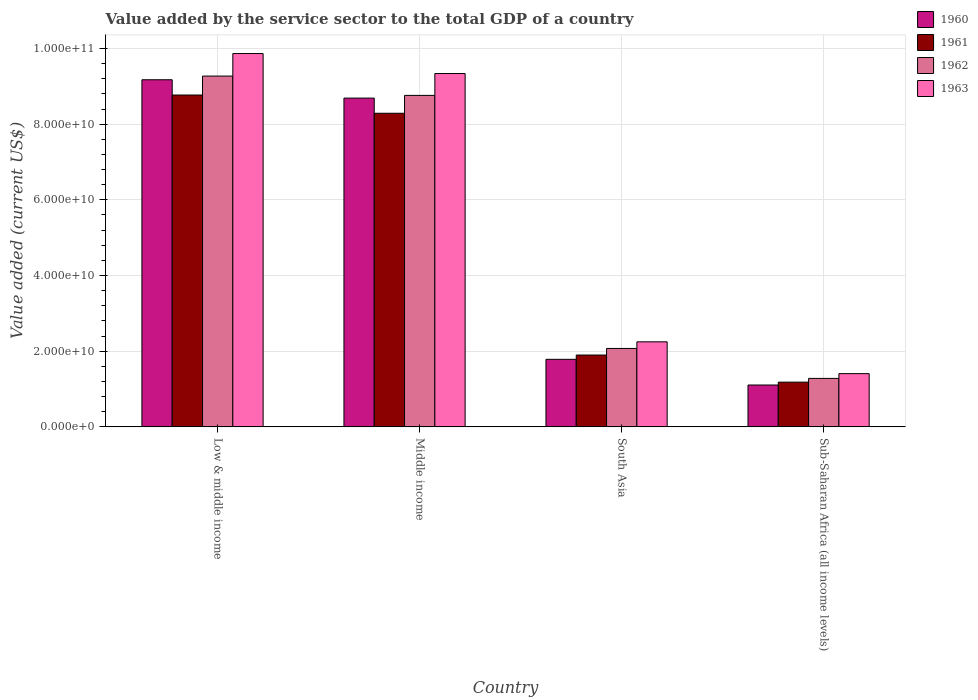How many groups of bars are there?
Offer a very short reply. 4. Are the number of bars per tick equal to the number of legend labels?
Give a very brief answer. Yes. How many bars are there on the 2nd tick from the left?
Your answer should be very brief. 4. What is the value added by the service sector to the total GDP in 1961 in Low & middle income?
Your answer should be compact. 8.77e+1. Across all countries, what is the maximum value added by the service sector to the total GDP in 1962?
Your answer should be very brief. 9.27e+1. Across all countries, what is the minimum value added by the service sector to the total GDP in 1960?
Your response must be concise. 1.11e+1. In which country was the value added by the service sector to the total GDP in 1962 minimum?
Provide a succinct answer. Sub-Saharan Africa (all income levels). What is the total value added by the service sector to the total GDP in 1963 in the graph?
Provide a short and direct response. 2.29e+11. What is the difference between the value added by the service sector to the total GDP in 1963 in Low & middle income and that in South Asia?
Give a very brief answer. 7.62e+1. What is the difference between the value added by the service sector to the total GDP in 1962 in Sub-Saharan Africa (all income levels) and the value added by the service sector to the total GDP in 1963 in Low & middle income?
Make the answer very short. -8.58e+1. What is the average value added by the service sector to the total GDP in 1960 per country?
Your response must be concise. 5.19e+1. What is the difference between the value added by the service sector to the total GDP of/in 1961 and value added by the service sector to the total GDP of/in 1963 in Middle income?
Your response must be concise. -1.05e+1. What is the ratio of the value added by the service sector to the total GDP in 1962 in South Asia to that in Sub-Saharan Africa (all income levels)?
Your response must be concise. 1.62. What is the difference between the highest and the second highest value added by the service sector to the total GDP in 1963?
Your response must be concise. -5.28e+09. What is the difference between the highest and the lowest value added by the service sector to the total GDP in 1960?
Provide a short and direct response. 8.07e+1. What does the 3rd bar from the left in South Asia represents?
Provide a succinct answer. 1962. How many countries are there in the graph?
Give a very brief answer. 4. What is the difference between two consecutive major ticks on the Y-axis?
Provide a succinct answer. 2.00e+1. Does the graph contain grids?
Offer a terse response. Yes. How are the legend labels stacked?
Keep it short and to the point. Vertical. What is the title of the graph?
Offer a terse response. Value added by the service sector to the total GDP of a country. Does "1974" appear as one of the legend labels in the graph?
Your response must be concise. No. What is the label or title of the Y-axis?
Provide a succinct answer. Value added (current US$). What is the Value added (current US$) in 1960 in Low & middle income?
Your answer should be compact. 9.17e+1. What is the Value added (current US$) in 1961 in Low & middle income?
Offer a very short reply. 8.77e+1. What is the Value added (current US$) in 1962 in Low & middle income?
Ensure brevity in your answer.  9.27e+1. What is the Value added (current US$) of 1963 in Low & middle income?
Keep it short and to the point. 9.87e+1. What is the Value added (current US$) of 1960 in Middle income?
Offer a very short reply. 8.69e+1. What is the Value added (current US$) of 1961 in Middle income?
Your response must be concise. 8.29e+1. What is the Value added (current US$) of 1962 in Middle income?
Provide a short and direct response. 8.76e+1. What is the Value added (current US$) of 1963 in Middle income?
Your response must be concise. 9.34e+1. What is the Value added (current US$) of 1960 in South Asia?
Offer a terse response. 1.79e+1. What is the Value added (current US$) of 1961 in South Asia?
Ensure brevity in your answer.  1.90e+1. What is the Value added (current US$) in 1962 in South Asia?
Your response must be concise. 2.07e+1. What is the Value added (current US$) of 1963 in South Asia?
Your answer should be very brief. 2.25e+1. What is the Value added (current US$) of 1960 in Sub-Saharan Africa (all income levels)?
Your response must be concise. 1.11e+1. What is the Value added (current US$) in 1961 in Sub-Saharan Africa (all income levels)?
Offer a terse response. 1.18e+1. What is the Value added (current US$) of 1962 in Sub-Saharan Africa (all income levels)?
Your answer should be very brief. 1.28e+1. What is the Value added (current US$) in 1963 in Sub-Saharan Africa (all income levels)?
Make the answer very short. 1.41e+1. Across all countries, what is the maximum Value added (current US$) of 1960?
Make the answer very short. 9.17e+1. Across all countries, what is the maximum Value added (current US$) in 1961?
Keep it short and to the point. 8.77e+1. Across all countries, what is the maximum Value added (current US$) in 1962?
Offer a terse response. 9.27e+1. Across all countries, what is the maximum Value added (current US$) in 1963?
Provide a succinct answer. 9.87e+1. Across all countries, what is the minimum Value added (current US$) of 1960?
Provide a succinct answer. 1.11e+1. Across all countries, what is the minimum Value added (current US$) of 1961?
Your answer should be very brief. 1.18e+1. Across all countries, what is the minimum Value added (current US$) of 1962?
Your answer should be very brief. 1.28e+1. Across all countries, what is the minimum Value added (current US$) of 1963?
Your response must be concise. 1.41e+1. What is the total Value added (current US$) in 1960 in the graph?
Make the answer very short. 2.08e+11. What is the total Value added (current US$) in 1961 in the graph?
Your answer should be compact. 2.01e+11. What is the total Value added (current US$) of 1962 in the graph?
Keep it short and to the point. 2.14e+11. What is the total Value added (current US$) of 1963 in the graph?
Your response must be concise. 2.29e+11. What is the difference between the Value added (current US$) of 1960 in Low & middle income and that in Middle income?
Provide a succinct answer. 4.84e+09. What is the difference between the Value added (current US$) in 1961 in Low & middle income and that in Middle income?
Offer a terse response. 4.82e+09. What is the difference between the Value added (current US$) of 1962 in Low & middle income and that in Middle income?
Make the answer very short. 5.11e+09. What is the difference between the Value added (current US$) of 1963 in Low & middle income and that in Middle income?
Provide a short and direct response. 5.28e+09. What is the difference between the Value added (current US$) of 1960 in Low & middle income and that in South Asia?
Provide a succinct answer. 7.39e+1. What is the difference between the Value added (current US$) of 1961 in Low & middle income and that in South Asia?
Provide a short and direct response. 6.87e+1. What is the difference between the Value added (current US$) of 1962 in Low & middle income and that in South Asia?
Keep it short and to the point. 7.20e+1. What is the difference between the Value added (current US$) in 1963 in Low & middle income and that in South Asia?
Offer a terse response. 7.62e+1. What is the difference between the Value added (current US$) in 1960 in Low & middle income and that in Sub-Saharan Africa (all income levels)?
Ensure brevity in your answer.  8.07e+1. What is the difference between the Value added (current US$) of 1961 in Low & middle income and that in Sub-Saharan Africa (all income levels)?
Give a very brief answer. 7.59e+1. What is the difference between the Value added (current US$) of 1962 in Low & middle income and that in Sub-Saharan Africa (all income levels)?
Offer a very short reply. 7.99e+1. What is the difference between the Value added (current US$) of 1963 in Low & middle income and that in Sub-Saharan Africa (all income levels)?
Your response must be concise. 8.46e+1. What is the difference between the Value added (current US$) in 1960 in Middle income and that in South Asia?
Offer a very short reply. 6.90e+1. What is the difference between the Value added (current US$) of 1961 in Middle income and that in South Asia?
Keep it short and to the point. 6.39e+1. What is the difference between the Value added (current US$) of 1962 in Middle income and that in South Asia?
Ensure brevity in your answer.  6.69e+1. What is the difference between the Value added (current US$) of 1963 in Middle income and that in South Asia?
Offer a terse response. 7.09e+1. What is the difference between the Value added (current US$) of 1960 in Middle income and that in Sub-Saharan Africa (all income levels)?
Offer a terse response. 7.58e+1. What is the difference between the Value added (current US$) of 1961 in Middle income and that in Sub-Saharan Africa (all income levels)?
Provide a short and direct response. 7.11e+1. What is the difference between the Value added (current US$) in 1962 in Middle income and that in Sub-Saharan Africa (all income levels)?
Offer a very short reply. 7.48e+1. What is the difference between the Value added (current US$) in 1963 in Middle income and that in Sub-Saharan Africa (all income levels)?
Offer a very short reply. 7.93e+1. What is the difference between the Value added (current US$) of 1960 in South Asia and that in Sub-Saharan Africa (all income levels)?
Make the answer very short. 6.79e+09. What is the difference between the Value added (current US$) in 1961 in South Asia and that in Sub-Saharan Africa (all income levels)?
Give a very brief answer. 7.17e+09. What is the difference between the Value added (current US$) of 1962 in South Asia and that in Sub-Saharan Africa (all income levels)?
Your response must be concise. 7.91e+09. What is the difference between the Value added (current US$) in 1963 in South Asia and that in Sub-Saharan Africa (all income levels)?
Provide a short and direct response. 8.41e+09. What is the difference between the Value added (current US$) in 1960 in Low & middle income and the Value added (current US$) in 1961 in Middle income?
Your answer should be compact. 8.85e+09. What is the difference between the Value added (current US$) in 1960 in Low & middle income and the Value added (current US$) in 1962 in Middle income?
Your response must be concise. 4.13e+09. What is the difference between the Value added (current US$) in 1960 in Low & middle income and the Value added (current US$) in 1963 in Middle income?
Provide a succinct answer. -1.65e+09. What is the difference between the Value added (current US$) of 1961 in Low & middle income and the Value added (current US$) of 1962 in Middle income?
Offer a very short reply. 9.90e+07. What is the difference between the Value added (current US$) in 1961 in Low & middle income and the Value added (current US$) in 1963 in Middle income?
Give a very brief answer. -5.68e+09. What is the difference between the Value added (current US$) of 1962 in Low & middle income and the Value added (current US$) of 1963 in Middle income?
Your answer should be compact. -6.73e+08. What is the difference between the Value added (current US$) of 1960 in Low & middle income and the Value added (current US$) of 1961 in South Asia?
Provide a short and direct response. 7.27e+1. What is the difference between the Value added (current US$) of 1960 in Low & middle income and the Value added (current US$) of 1962 in South Asia?
Your answer should be very brief. 7.10e+1. What is the difference between the Value added (current US$) of 1960 in Low & middle income and the Value added (current US$) of 1963 in South Asia?
Keep it short and to the point. 6.93e+1. What is the difference between the Value added (current US$) in 1961 in Low & middle income and the Value added (current US$) in 1962 in South Asia?
Your answer should be very brief. 6.70e+1. What is the difference between the Value added (current US$) in 1961 in Low & middle income and the Value added (current US$) in 1963 in South Asia?
Your response must be concise. 6.52e+1. What is the difference between the Value added (current US$) of 1962 in Low & middle income and the Value added (current US$) of 1963 in South Asia?
Make the answer very short. 7.02e+1. What is the difference between the Value added (current US$) in 1960 in Low & middle income and the Value added (current US$) in 1961 in Sub-Saharan Africa (all income levels)?
Provide a succinct answer. 7.99e+1. What is the difference between the Value added (current US$) in 1960 in Low & middle income and the Value added (current US$) in 1962 in Sub-Saharan Africa (all income levels)?
Provide a succinct answer. 7.89e+1. What is the difference between the Value added (current US$) of 1960 in Low & middle income and the Value added (current US$) of 1963 in Sub-Saharan Africa (all income levels)?
Give a very brief answer. 7.77e+1. What is the difference between the Value added (current US$) in 1961 in Low & middle income and the Value added (current US$) in 1962 in Sub-Saharan Africa (all income levels)?
Provide a short and direct response. 7.49e+1. What is the difference between the Value added (current US$) of 1961 in Low & middle income and the Value added (current US$) of 1963 in Sub-Saharan Africa (all income levels)?
Offer a terse response. 7.36e+1. What is the difference between the Value added (current US$) of 1962 in Low & middle income and the Value added (current US$) of 1963 in Sub-Saharan Africa (all income levels)?
Provide a succinct answer. 7.86e+1. What is the difference between the Value added (current US$) of 1960 in Middle income and the Value added (current US$) of 1961 in South Asia?
Keep it short and to the point. 6.79e+1. What is the difference between the Value added (current US$) in 1960 in Middle income and the Value added (current US$) in 1962 in South Asia?
Keep it short and to the point. 6.62e+1. What is the difference between the Value added (current US$) of 1960 in Middle income and the Value added (current US$) of 1963 in South Asia?
Offer a terse response. 6.44e+1. What is the difference between the Value added (current US$) of 1961 in Middle income and the Value added (current US$) of 1962 in South Asia?
Keep it short and to the point. 6.22e+1. What is the difference between the Value added (current US$) of 1961 in Middle income and the Value added (current US$) of 1963 in South Asia?
Your answer should be compact. 6.04e+1. What is the difference between the Value added (current US$) in 1962 in Middle income and the Value added (current US$) in 1963 in South Asia?
Keep it short and to the point. 6.51e+1. What is the difference between the Value added (current US$) of 1960 in Middle income and the Value added (current US$) of 1961 in Sub-Saharan Africa (all income levels)?
Ensure brevity in your answer.  7.51e+1. What is the difference between the Value added (current US$) of 1960 in Middle income and the Value added (current US$) of 1962 in Sub-Saharan Africa (all income levels)?
Provide a succinct answer. 7.41e+1. What is the difference between the Value added (current US$) in 1960 in Middle income and the Value added (current US$) in 1963 in Sub-Saharan Africa (all income levels)?
Your answer should be very brief. 7.28e+1. What is the difference between the Value added (current US$) of 1961 in Middle income and the Value added (current US$) of 1962 in Sub-Saharan Africa (all income levels)?
Offer a very short reply. 7.01e+1. What is the difference between the Value added (current US$) of 1961 in Middle income and the Value added (current US$) of 1963 in Sub-Saharan Africa (all income levels)?
Provide a short and direct response. 6.88e+1. What is the difference between the Value added (current US$) in 1962 in Middle income and the Value added (current US$) in 1963 in Sub-Saharan Africa (all income levels)?
Provide a short and direct response. 7.35e+1. What is the difference between the Value added (current US$) in 1960 in South Asia and the Value added (current US$) in 1961 in Sub-Saharan Africa (all income levels)?
Your response must be concise. 6.03e+09. What is the difference between the Value added (current US$) of 1960 in South Asia and the Value added (current US$) of 1962 in Sub-Saharan Africa (all income levels)?
Offer a terse response. 5.04e+09. What is the difference between the Value added (current US$) of 1960 in South Asia and the Value added (current US$) of 1963 in Sub-Saharan Africa (all income levels)?
Offer a terse response. 3.78e+09. What is the difference between the Value added (current US$) in 1961 in South Asia and the Value added (current US$) in 1962 in Sub-Saharan Africa (all income levels)?
Make the answer very short. 6.17e+09. What is the difference between the Value added (current US$) in 1961 in South Asia and the Value added (current US$) in 1963 in Sub-Saharan Africa (all income levels)?
Provide a short and direct response. 4.91e+09. What is the difference between the Value added (current US$) in 1962 in South Asia and the Value added (current US$) in 1963 in Sub-Saharan Africa (all income levels)?
Keep it short and to the point. 6.65e+09. What is the average Value added (current US$) of 1960 per country?
Give a very brief answer. 5.19e+1. What is the average Value added (current US$) in 1961 per country?
Offer a very short reply. 5.03e+1. What is the average Value added (current US$) in 1962 per country?
Your answer should be compact. 5.35e+1. What is the average Value added (current US$) in 1963 per country?
Make the answer very short. 5.71e+1. What is the difference between the Value added (current US$) of 1960 and Value added (current US$) of 1961 in Low & middle income?
Offer a very short reply. 4.03e+09. What is the difference between the Value added (current US$) of 1960 and Value added (current US$) of 1962 in Low & middle income?
Your answer should be very brief. -9.77e+08. What is the difference between the Value added (current US$) in 1960 and Value added (current US$) in 1963 in Low & middle income?
Provide a succinct answer. -6.93e+09. What is the difference between the Value added (current US$) in 1961 and Value added (current US$) in 1962 in Low & middle income?
Provide a succinct answer. -5.01e+09. What is the difference between the Value added (current US$) of 1961 and Value added (current US$) of 1963 in Low & middle income?
Give a very brief answer. -1.10e+1. What is the difference between the Value added (current US$) in 1962 and Value added (current US$) in 1963 in Low & middle income?
Your answer should be compact. -5.95e+09. What is the difference between the Value added (current US$) in 1960 and Value added (current US$) in 1961 in Middle income?
Provide a succinct answer. 4.01e+09. What is the difference between the Value added (current US$) in 1960 and Value added (current US$) in 1962 in Middle income?
Your response must be concise. -7.11e+08. What is the difference between the Value added (current US$) in 1960 and Value added (current US$) in 1963 in Middle income?
Provide a short and direct response. -6.49e+09. What is the difference between the Value added (current US$) of 1961 and Value added (current US$) of 1962 in Middle income?
Keep it short and to the point. -4.72e+09. What is the difference between the Value added (current US$) in 1961 and Value added (current US$) in 1963 in Middle income?
Provide a succinct answer. -1.05e+1. What is the difference between the Value added (current US$) of 1962 and Value added (current US$) of 1963 in Middle income?
Offer a very short reply. -5.78e+09. What is the difference between the Value added (current US$) of 1960 and Value added (current US$) of 1961 in South Asia?
Offer a very short reply. -1.13e+09. What is the difference between the Value added (current US$) in 1960 and Value added (current US$) in 1962 in South Asia?
Your answer should be compact. -2.87e+09. What is the difference between the Value added (current US$) of 1960 and Value added (current US$) of 1963 in South Asia?
Provide a short and direct response. -4.62e+09. What is the difference between the Value added (current US$) of 1961 and Value added (current US$) of 1962 in South Asia?
Give a very brief answer. -1.74e+09. What is the difference between the Value added (current US$) of 1961 and Value added (current US$) of 1963 in South Asia?
Your answer should be compact. -3.49e+09. What is the difference between the Value added (current US$) of 1962 and Value added (current US$) of 1963 in South Asia?
Your response must be concise. -1.75e+09. What is the difference between the Value added (current US$) in 1960 and Value added (current US$) in 1961 in Sub-Saharan Africa (all income levels)?
Make the answer very short. -7.53e+08. What is the difference between the Value added (current US$) of 1960 and Value added (current US$) of 1962 in Sub-Saharan Africa (all income levels)?
Your response must be concise. -1.75e+09. What is the difference between the Value added (current US$) in 1960 and Value added (current US$) in 1963 in Sub-Saharan Africa (all income levels)?
Ensure brevity in your answer.  -3.01e+09. What is the difference between the Value added (current US$) in 1961 and Value added (current US$) in 1962 in Sub-Saharan Africa (all income levels)?
Make the answer very short. -9.94e+08. What is the difference between the Value added (current US$) of 1961 and Value added (current US$) of 1963 in Sub-Saharan Africa (all income levels)?
Ensure brevity in your answer.  -2.25e+09. What is the difference between the Value added (current US$) of 1962 and Value added (current US$) of 1963 in Sub-Saharan Africa (all income levels)?
Give a very brief answer. -1.26e+09. What is the ratio of the Value added (current US$) of 1960 in Low & middle income to that in Middle income?
Give a very brief answer. 1.06. What is the ratio of the Value added (current US$) in 1961 in Low & middle income to that in Middle income?
Offer a terse response. 1.06. What is the ratio of the Value added (current US$) in 1962 in Low & middle income to that in Middle income?
Your answer should be very brief. 1.06. What is the ratio of the Value added (current US$) in 1963 in Low & middle income to that in Middle income?
Keep it short and to the point. 1.06. What is the ratio of the Value added (current US$) of 1960 in Low & middle income to that in South Asia?
Provide a short and direct response. 5.14. What is the ratio of the Value added (current US$) of 1961 in Low & middle income to that in South Asia?
Keep it short and to the point. 4.62. What is the ratio of the Value added (current US$) of 1962 in Low & middle income to that in South Asia?
Make the answer very short. 4.47. What is the ratio of the Value added (current US$) in 1963 in Low & middle income to that in South Asia?
Your response must be concise. 4.39. What is the ratio of the Value added (current US$) of 1960 in Low & middle income to that in Sub-Saharan Africa (all income levels)?
Keep it short and to the point. 8.29. What is the ratio of the Value added (current US$) of 1961 in Low & middle income to that in Sub-Saharan Africa (all income levels)?
Offer a very short reply. 7.42. What is the ratio of the Value added (current US$) of 1962 in Low & middle income to that in Sub-Saharan Africa (all income levels)?
Offer a terse response. 7.24. What is the ratio of the Value added (current US$) in 1963 in Low & middle income to that in Sub-Saharan Africa (all income levels)?
Make the answer very short. 7.01. What is the ratio of the Value added (current US$) of 1960 in Middle income to that in South Asia?
Your answer should be very brief. 4.87. What is the ratio of the Value added (current US$) of 1961 in Middle income to that in South Asia?
Offer a very short reply. 4.37. What is the ratio of the Value added (current US$) of 1962 in Middle income to that in South Asia?
Your answer should be very brief. 4.23. What is the ratio of the Value added (current US$) in 1963 in Middle income to that in South Asia?
Offer a terse response. 4.15. What is the ratio of the Value added (current US$) of 1960 in Middle income to that in Sub-Saharan Africa (all income levels)?
Your response must be concise. 7.85. What is the ratio of the Value added (current US$) in 1961 in Middle income to that in Sub-Saharan Africa (all income levels)?
Keep it short and to the point. 7.01. What is the ratio of the Value added (current US$) of 1962 in Middle income to that in Sub-Saharan Africa (all income levels)?
Your answer should be very brief. 6.84. What is the ratio of the Value added (current US$) of 1963 in Middle income to that in Sub-Saharan Africa (all income levels)?
Provide a succinct answer. 6.64. What is the ratio of the Value added (current US$) of 1960 in South Asia to that in Sub-Saharan Africa (all income levels)?
Ensure brevity in your answer.  1.61. What is the ratio of the Value added (current US$) of 1961 in South Asia to that in Sub-Saharan Africa (all income levels)?
Keep it short and to the point. 1.61. What is the ratio of the Value added (current US$) of 1962 in South Asia to that in Sub-Saharan Africa (all income levels)?
Provide a short and direct response. 1.62. What is the ratio of the Value added (current US$) in 1963 in South Asia to that in Sub-Saharan Africa (all income levels)?
Keep it short and to the point. 1.6. What is the difference between the highest and the second highest Value added (current US$) of 1960?
Give a very brief answer. 4.84e+09. What is the difference between the highest and the second highest Value added (current US$) in 1961?
Keep it short and to the point. 4.82e+09. What is the difference between the highest and the second highest Value added (current US$) in 1962?
Make the answer very short. 5.11e+09. What is the difference between the highest and the second highest Value added (current US$) of 1963?
Give a very brief answer. 5.28e+09. What is the difference between the highest and the lowest Value added (current US$) in 1960?
Provide a succinct answer. 8.07e+1. What is the difference between the highest and the lowest Value added (current US$) in 1961?
Provide a succinct answer. 7.59e+1. What is the difference between the highest and the lowest Value added (current US$) of 1962?
Your response must be concise. 7.99e+1. What is the difference between the highest and the lowest Value added (current US$) in 1963?
Give a very brief answer. 8.46e+1. 